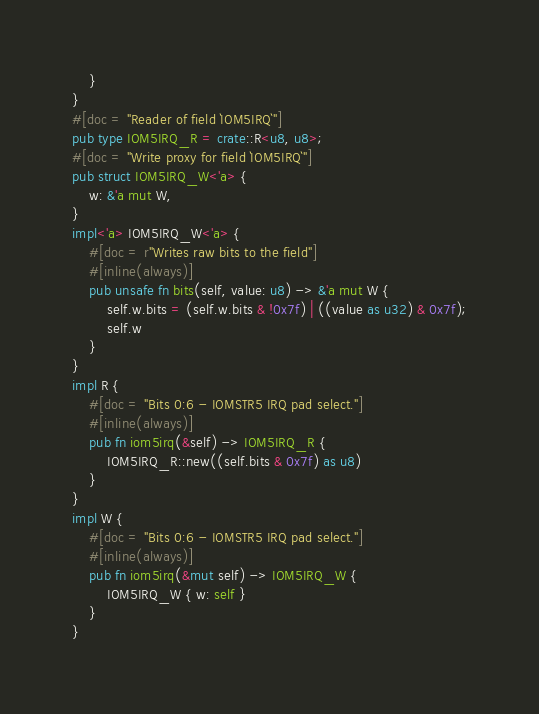<code> <loc_0><loc_0><loc_500><loc_500><_Rust_>    }
}
#[doc = "Reader of field `IOM5IRQ`"]
pub type IOM5IRQ_R = crate::R<u8, u8>;
#[doc = "Write proxy for field `IOM5IRQ`"]
pub struct IOM5IRQ_W<'a> {
    w: &'a mut W,
}
impl<'a> IOM5IRQ_W<'a> {
    #[doc = r"Writes raw bits to the field"]
    #[inline(always)]
    pub unsafe fn bits(self, value: u8) -> &'a mut W {
        self.w.bits = (self.w.bits & !0x7f) | ((value as u32) & 0x7f);
        self.w
    }
}
impl R {
    #[doc = "Bits 0:6 - IOMSTR5 IRQ pad select."]
    #[inline(always)]
    pub fn iom5irq(&self) -> IOM5IRQ_R {
        IOM5IRQ_R::new((self.bits & 0x7f) as u8)
    }
}
impl W {
    #[doc = "Bits 0:6 - IOMSTR5 IRQ pad select."]
    #[inline(always)]
    pub fn iom5irq(&mut self) -> IOM5IRQ_W {
        IOM5IRQ_W { w: self }
    }
}
</code> 